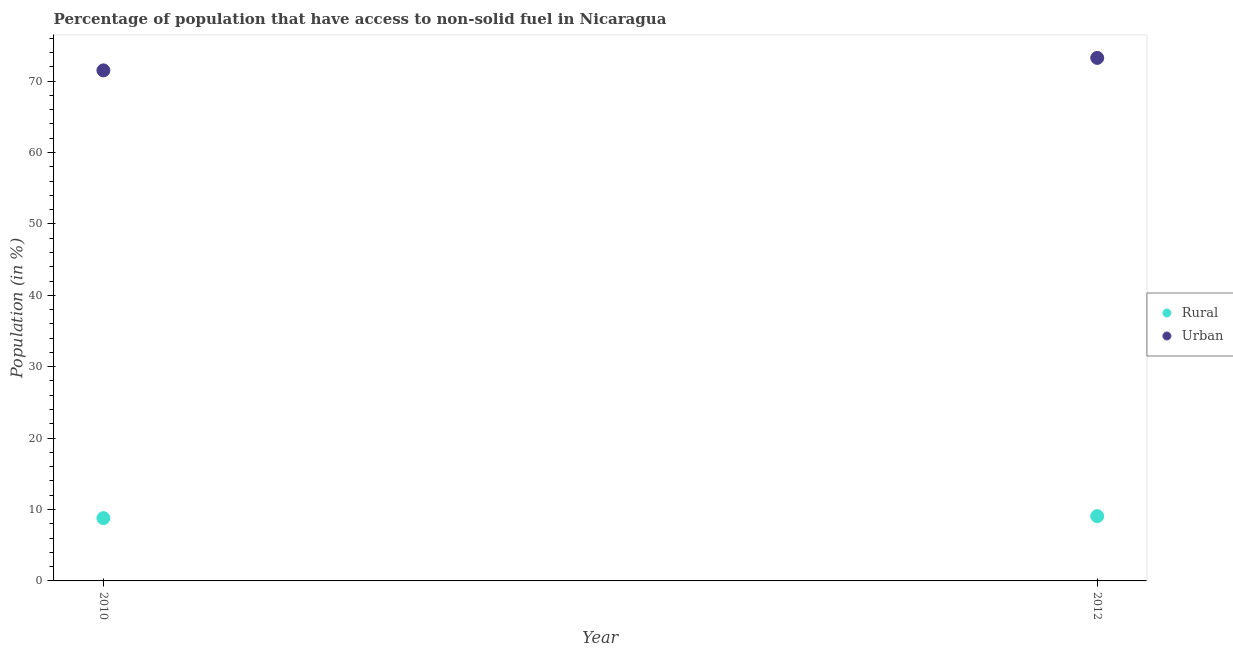What is the rural population in 2012?
Provide a short and direct response. 9.07. Across all years, what is the maximum urban population?
Keep it short and to the point. 73.25. Across all years, what is the minimum rural population?
Provide a succinct answer. 8.79. In which year was the urban population minimum?
Make the answer very short. 2010. What is the total urban population in the graph?
Give a very brief answer. 144.75. What is the difference between the rural population in 2010 and that in 2012?
Your answer should be very brief. -0.28. What is the difference between the urban population in 2010 and the rural population in 2012?
Keep it short and to the point. 62.43. What is the average rural population per year?
Your answer should be very brief. 8.93. In the year 2012, what is the difference between the urban population and rural population?
Keep it short and to the point. 64.18. What is the ratio of the rural population in 2010 to that in 2012?
Your response must be concise. 0.97. In how many years, is the urban population greater than the average urban population taken over all years?
Your response must be concise. 1. Is the rural population strictly greater than the urban population over the years?
Offer a very short reply. No. Are the values on the major ticks of Y-axis written in scientific E-notation?
Offer a very short reply. No. Does the graph contain grids?
Keep it short and to the point. No. How many legend labels are there?
Provide a succinct answer. 2. How are the legend labels stacked?
Provide a succinct answer. Vertical. What is the title of the graph?
Offer a terse response. Percentage of population that have access to non-solid fuel in Nicaragua. What is the label or title of the X-axis?
Make the answer very short. Year. What is the label or title of the Y-axis?
Give a very brief answer. Population (in %). What is the Population (in %) of Rural in 2010?
Provide a short and direct response. 8.79. What is the Population (in %) in Urban in 2010?
Offer a very short reply. 71.5. What is the Population (in %) in Rural in 2012?
Ensure brevity in your answer.  9.07. What is the Population (in %) in Urban in 2012?
Offer a very short reply. 73.25. Across all years, what is the maximum Population (in %) in Rural?
Provide a short and direct response. 9.07. Across all years, what is the maximum Population (in %) of Urban?
Keep it short and to the point. 73.25. Across all years, what is the minimum Population (in %) of Rural?
Your answer should be very brief. 8.79. Across all years, what is the minimum Population (in %) of Urban?
Make the answer very short. 71.5. What is the total Population (in %) in Rural in the graph?
Keep it short and to the point. 17.87. What is the total Population (in %) of Urban in the graph?
Provide a succinct answer. 144.75. What is the difference between the Population (in %) of Rural in 2010 and that in 2012?
Your response must be concise. -0.28. What is the difference between the Population (in %) of Urban in 2010 and that in 2012?
Keep it short and to the point. -1.75. What is the difference between the Population (in %) in Rural in 2010 and the Population (in %) in Urban in 2012?
Your answer should be very brief. -64.45. What is the average Population (in %) in Rural per year?
Make the answer very short. 8.93. What is the average Population (in %) in Urban per year?
Ensure brevity in your answer.  72.37. In the year 2010, what is the difference between the Population (in %) of Rural and Population (in %) of Urban?
Provide a short and direct response. -62.7. In the year 2012, what is the difference between the Population (in %) of Rural and Population (in %) of Urban?
Your response must be concise. -64.18. What is the ratio of the Population (in %) in Rural in 2010 to that in 2012?
Offer a very short reply. 0.97. What is the ratio of the Population (in %) in Urban in 2010 to that in 2012?
Ensure brevity in your answer.  0.98. What is the difference between the highest and the second highest Population (in %) in Rural?
Offer a very short reply. 0.28. What is the difference between the highest and the second highest Population (in %) in Urban?
Keep it short and to the point. 1.75. What is the difference between the highest and the lowest Population (in %) in Rural?
Offer a terse response. 0.28. What is the difference between the highest and the lowest Population (in %) of Urban?
Provide a short and direct response. 1.75. 